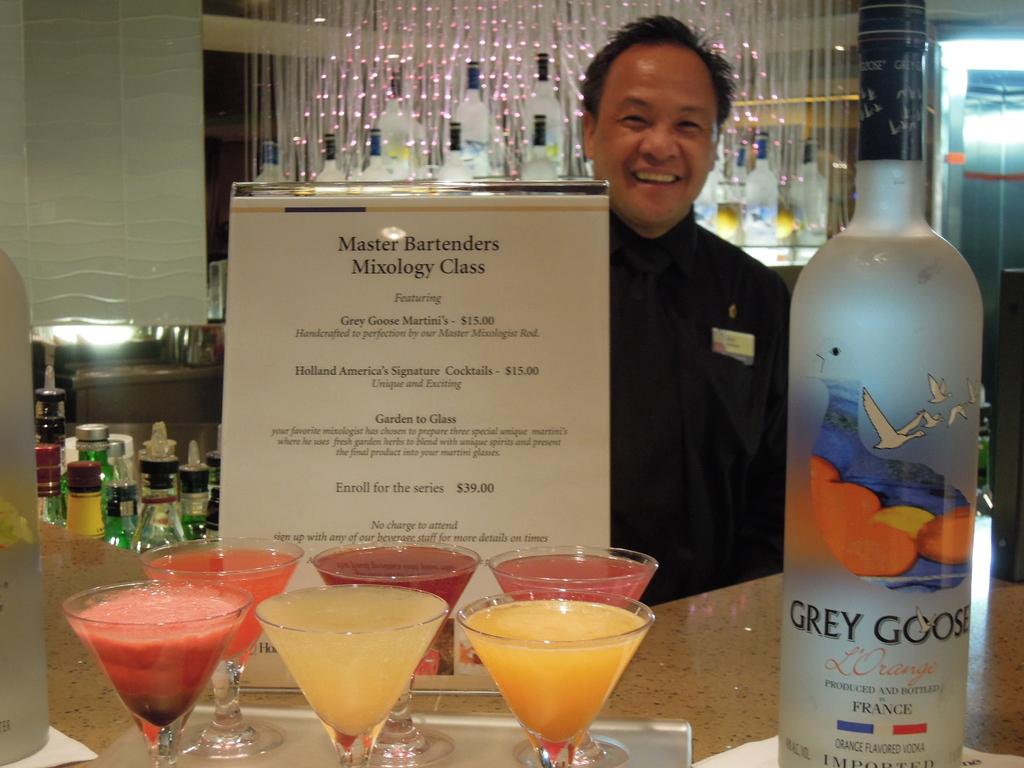What kind of vodka is displayed?
Ensure brevity in your answer.  Grey goose. What country is this vodka from?
Keep it short and to the point. France. 